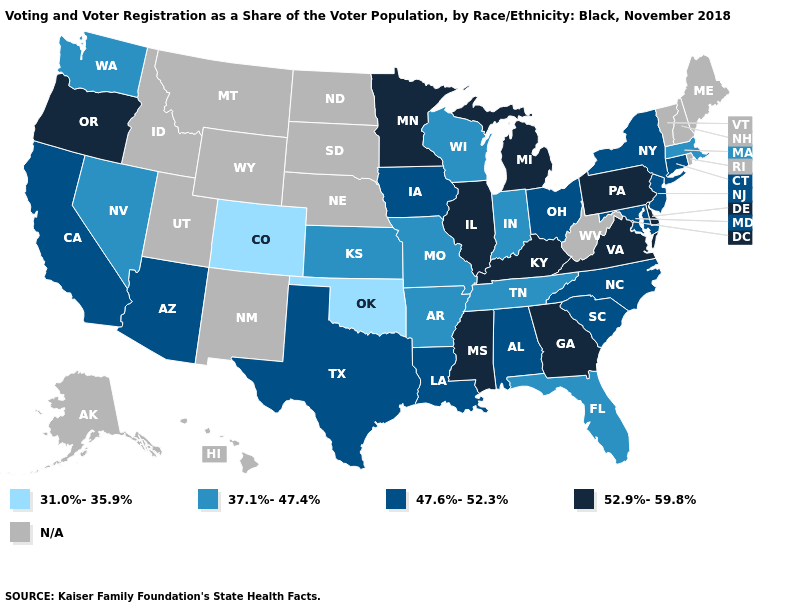Among the states that border Kentucky , which have the lowest value?
Write a very short answer. Indiana, Missouri, Tennessee. Among the states that border Connecticut , which have the lowest value?
Concise answer only. Massachusetts. What is the value of Alabama?
Concise answer only. 47.6%-52.3%. What is the value of Tennessee?
Give a very brief answer. 37.1%-47.4%. What is the value of Maryland?
Concise answer only. 47.6%-52.3%. What is the value of South Dakota?
Be succinct. N/A. What is the value of Connecticut?
Keep it brief. 47.6%-52.3%. Among the states that border Nevada , which have the highest value?
Answer briefly. Oregon. Name the states that have a value in the range 52.9%-59.8%?
Quick response, please. Delaware, Georgia, Illinois, Kentucky, Michigan, Minnesota, Mississippi, Oregon, Pennsylvania, Virginia. Name the states that have a value in the range 31.0%-35.9%?
Give a very brief answer. Colorado, Oklahoma. What is the value of Alaska?
Write a very short answer. N/A. Among the states that border Delaware , which have the highest value?
Give a very brief answer. Pennsylvania. What is the value of Montana?
Be succinct. N/A. 